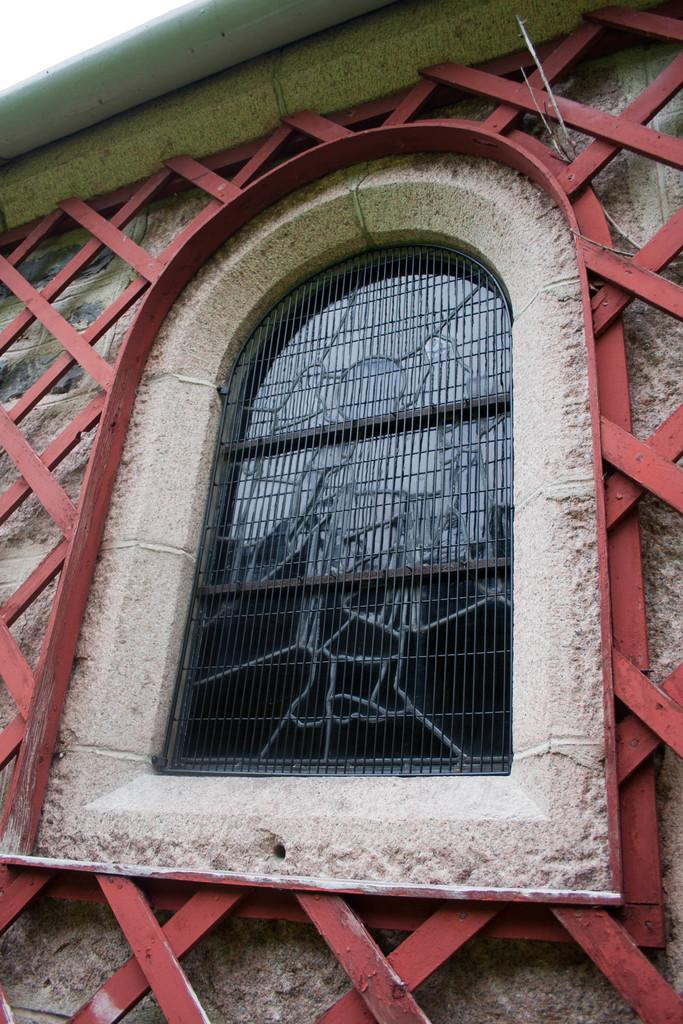Where was the image taken? The image was taken outdoors. What can be seen on the wall in the image? There is a window and grills on the wall in the image. How does the rabbit use the mitten in the image? There is no rabbit or mitten present in the image. 